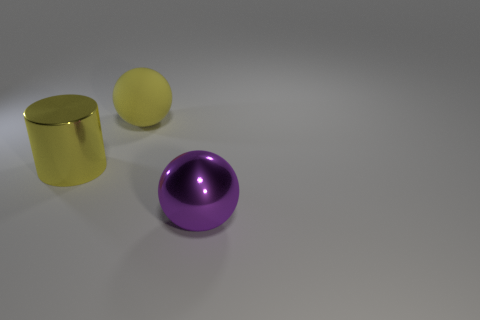What can the lighting and shadows in the image tell us about the environment? The lighting and shadows suggest a single light source above and to the right of the objects, creating soft but distinct shadows to the lower left side. This implies the objects are in a controlled setting with a primary light source, such as a studio setup. 